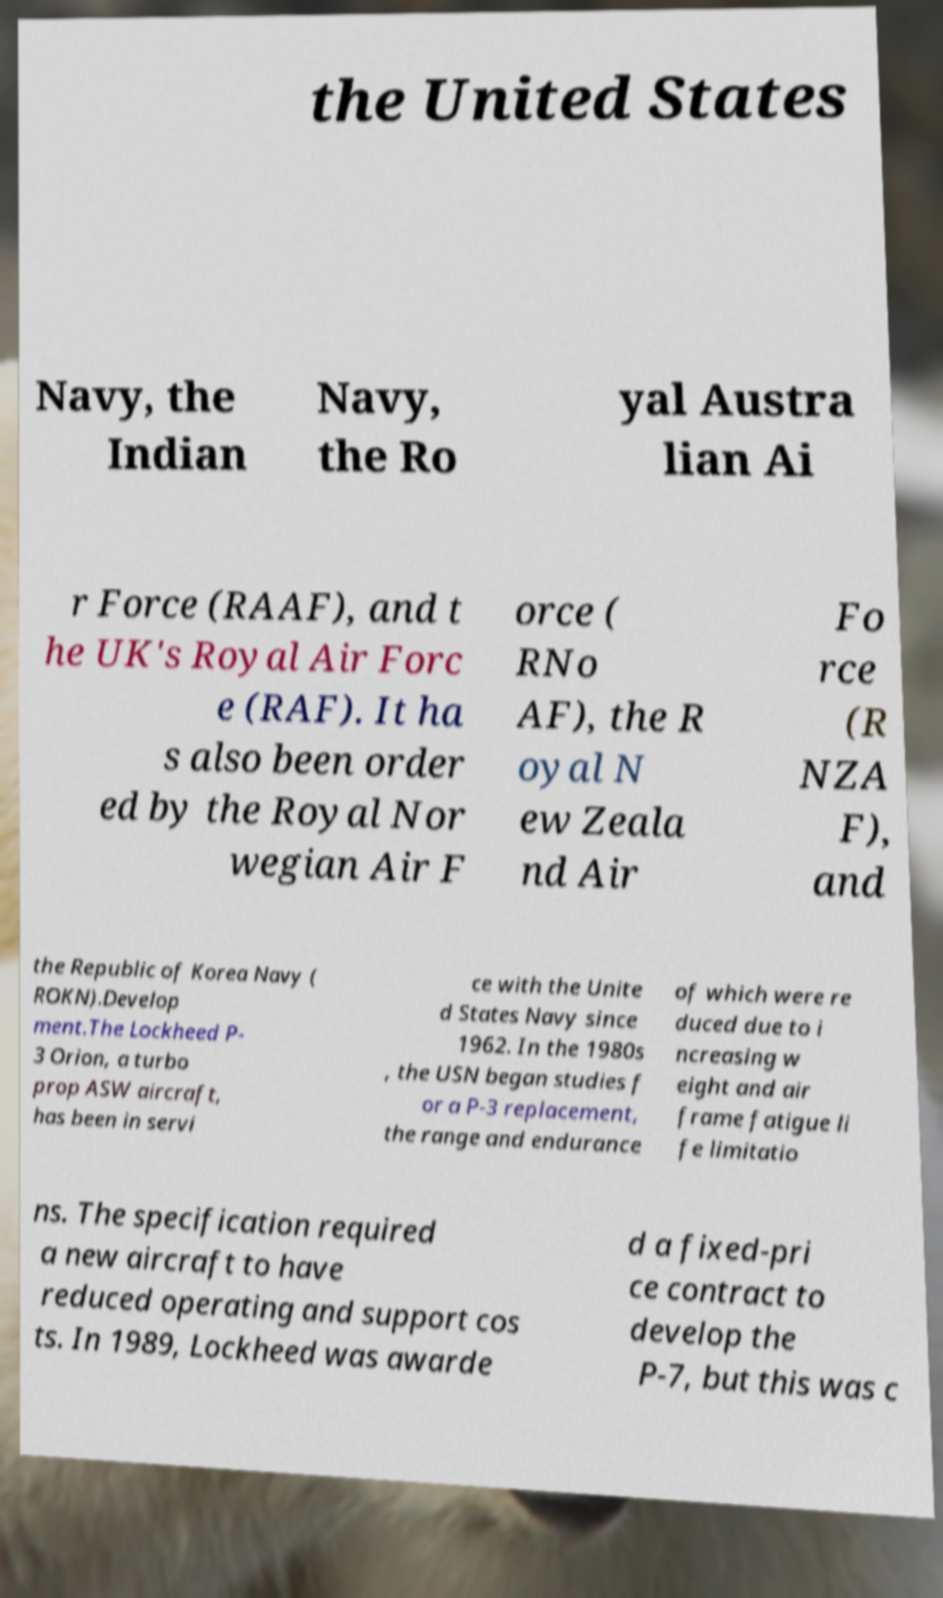What messages or text are displayed in this image? I need them in a readable, typed format. the United States Navy, the Indian Navy, the Ro yal Austra lian Ai r Force (RAAF), and t he UK's Royal Air Forc e (RAF). It ha s also been order ed by the Royal Nor wegian Air F orce ( RNo AF), the R oyal N ew Zeala nd Air Fo rce (R NZA F), and the Republic of Korea Navy ( ROKN).Develop ment.The Lockheed P- 3 Orion, a turbo prop ASW aircraft, has been in servi ce with the Unite d States Navy since 1962. In the 1980s , the USN began studies f or a P-3 replacement, the range and endurance of which were re duced due to i ncreasing w eight and air frame fatigue li fe limitatio ns. The specification required a new aircraft to have reduced operating and support cos ts. In 1989, Lockheed was awarde d a fixed-pri ce contract to develop the P-7, but this was c 